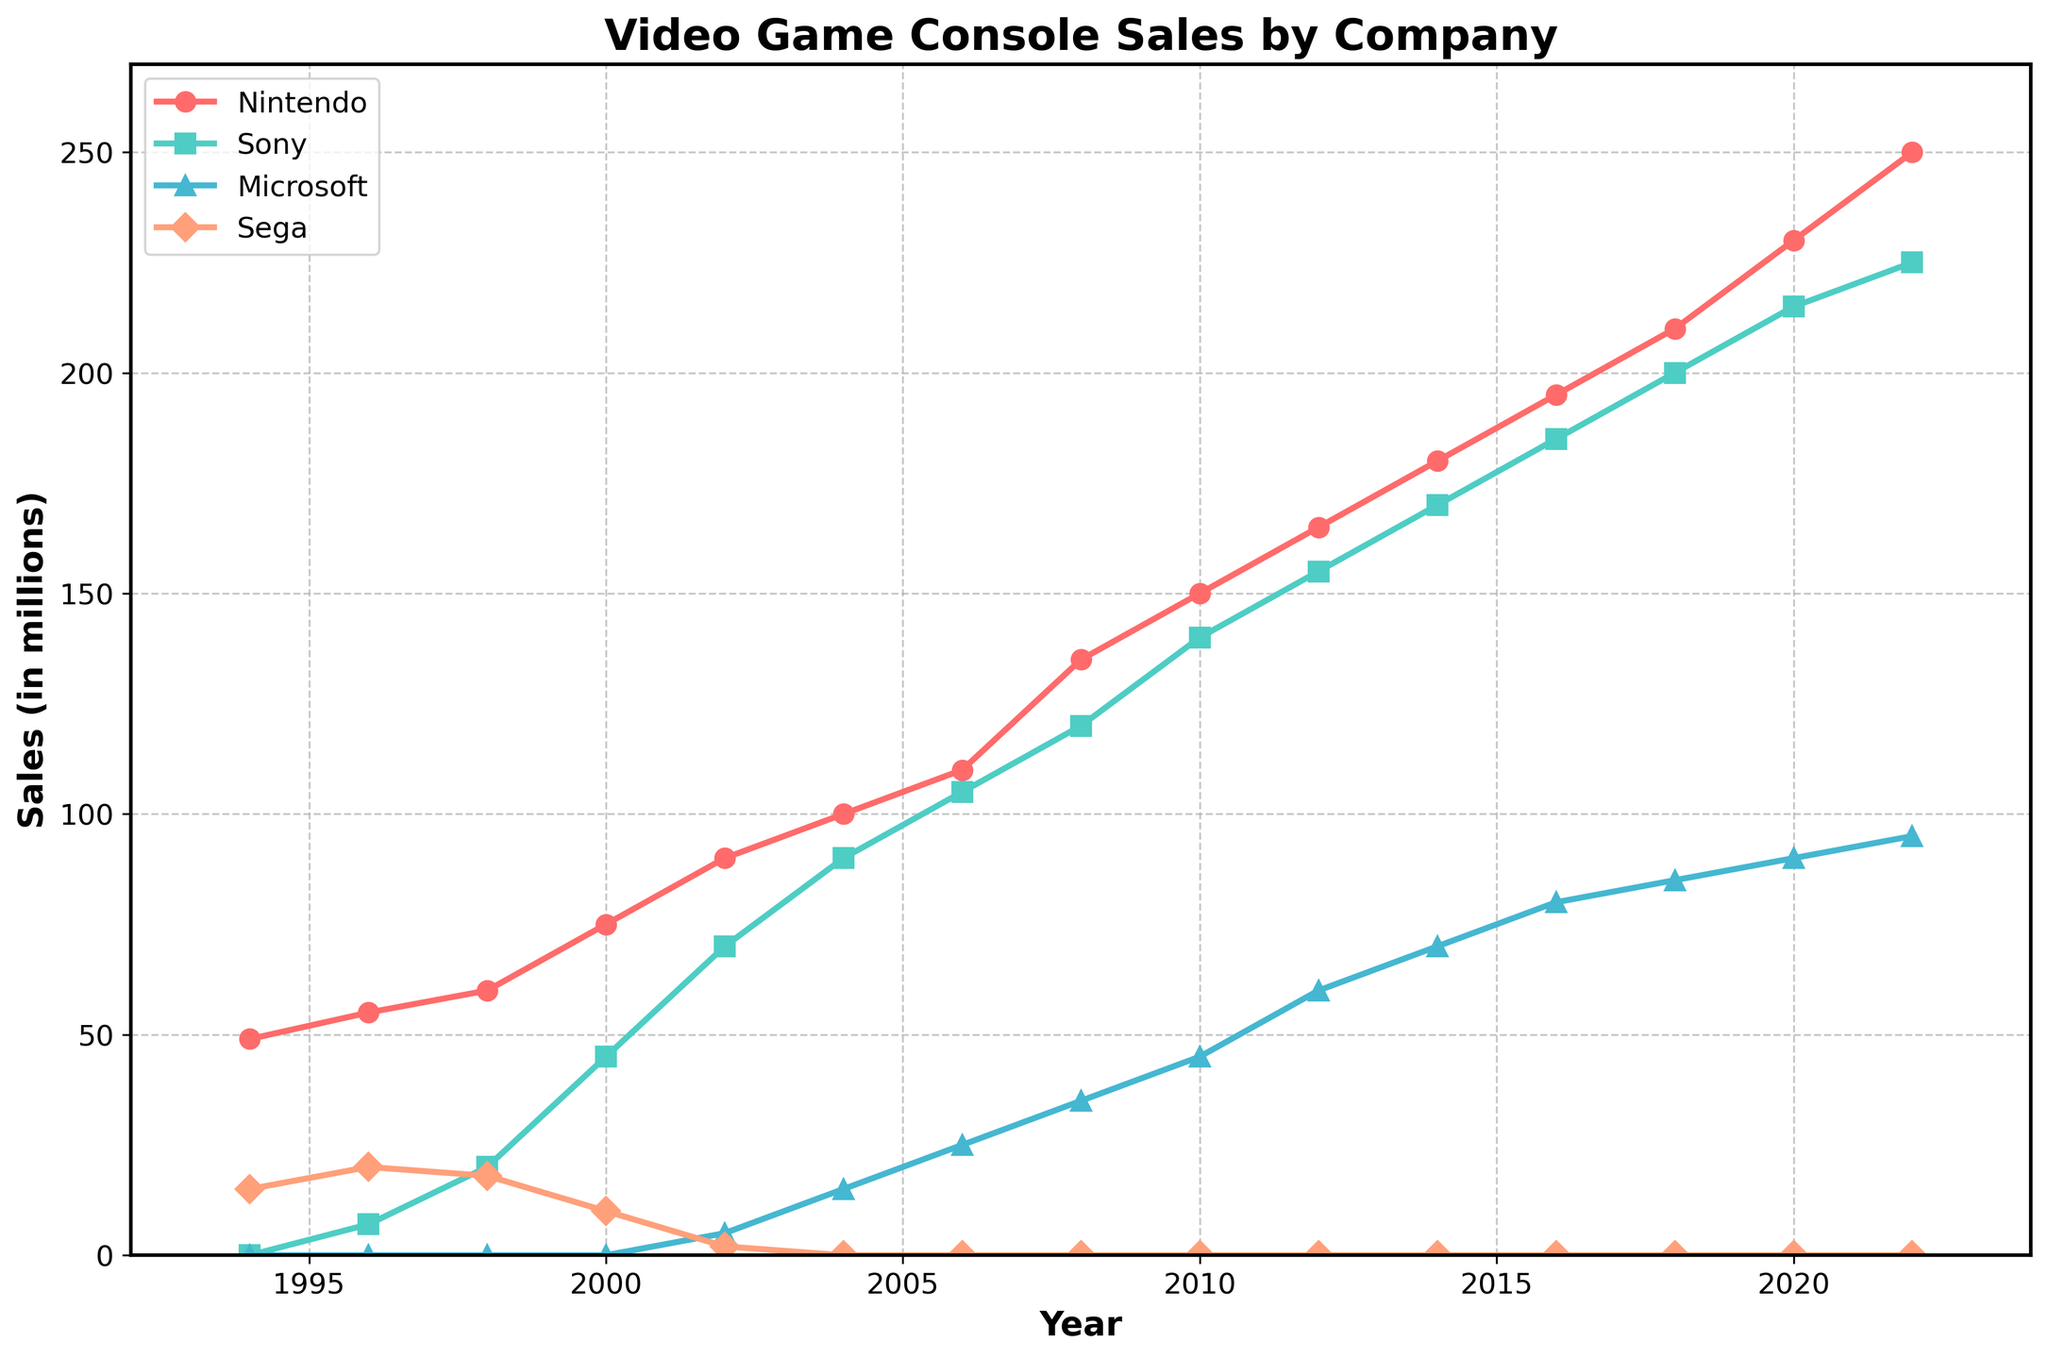What year shows the highest sales for Sega? Look for the point on the Sega line that has the highest value on the vertical axis. The highest sales occur in 1996, where Sega has sales of 20 million units.
Answer: 1996 Which company had the highest sales in 2018? Look at the sales values for all companies in 2018. Nintendo's value is 210, Sony's is 200, Microsoft's is 85, and Sega is not present in 2018. Thus, Nintendo had the highest sales in 2018.
Answer: Nintendo In which year did Microsoft first reach 20 million sales? Follow Microsoft's sales line and find the first year where it reaches 20 million. Microsoft did not reach 20 million sales until 2006.
Answer: 2006 How do the sales of Nintendo in 2006 compare to the combined sales of Microsoft and Sega in 1994? Check Nintendo's sales in 2006, which are 110 million. Then, sum Microsoft's and Sega's sales in 1994 (0 + 15). Nintendo's sales in 2006 are 110 million, and the combined sales of Microsoft and Sega in 1994 are 15 million, which is much less.
Answer: Nintendo's sales in 2006 are higher Which company showed the largest increase in sales between 2000 and 2002? Calculate the difference in sales for each company between 2000 and 2002: Nintendo (90-75=15), Sony (70-45=25), Microsoft (5-0=5), Sega (2-10=-8). Sony had the largest increase of 25 million.
Answer: Sony What is the combined sales for Nintendo and Sony in 2014? Look at the sales figures for Nintendo and Sony in 2014: 180 million for Nintendo and 170 million for Sony. Add them: 180 + 170 = 350 million.
Answer: 350 million Compare the trends of Nintendo and Sony from 1994 to 2022. Which company shows a more consistent growth over the years? Observe the slopes of the lines representing Nintendo and Sony. Nintendo shows a steady and consistent upward trend, while Sony's growth includes significant jumps, especially from 2000 to 2002, indicating less consistent growth.
Answer: Nintendo Which company ended with the lowest sales figure in 2022? Compare the sales figures of all companies in 2022. Nintendo (250), Sony (225), Microsoft (95). Sega does not appear in 2022. Microsoft has the lowest sales figure.
Answer: Microsoft At what year did Sony surpass Nintendo in sales for the first time? Look for the year where Sony's sales line crosses above Nintendo's sales line for the first time. This occurs around the year 2006.
Answer: 2006 What is the sales difference between Nintendo and Microsoft in 2010? Subtract Microsoft's sales from Nintendo's sales in 2010: 150 (Nintendo) - 45 (Microsoft) = 105 million.
Answer: 105 million 